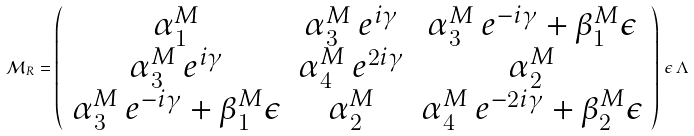Convert formula to latex. <formula><loc_0><loc_0><loc_500><loc_500>\mathcal { M } _ { R } = \left ( \begin{array} { c c c } \alpha ^ { M } _ { 1 } & \alpha ^ { M } _ { 3 } \, e ^ { i \gamma } & \alpha ^ { M } _ { 3 } \, e ^ { - i \gamma } + \beta ^ { M } _ { 1 } \epsilon \\ \alpha ^ { M } _ { 3 } \, e ^ { i \gamma } & \alpha ^ { M } _ { 4 } \, e ^ { 2 i \gamma } & \alpha ^ { M } _ { 2 } \\ \alpha ^ { M } _ { 3 } \, e ^ { - i \gamma } + \beta ^ { M } _ { 1 } \epsilon & \alpha ^ { M } _ { 2 } & \alpha ^ { M } _ { 4 } \, e ^ { - 2 i \gamma } + \beta ^ { M } _ { 2 } \epsilon \\ \end{array} \right ) \, \epsilon \, \Lambda</formula> 